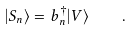<formula> <loc_0><loc_0><loc_500><loc_500>| S _ { n } \rangle = b _ { n } ^ { \dagger } | V \rangle \quad .</formula> 